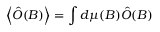Convert formula to latex. <formula><loc_0><loc_0><loc_500><loc_500>\left \langle \hat { O } ( B ) \right \rangle = \int d \mu ( B ) \hat { O } ( B )</formula> 